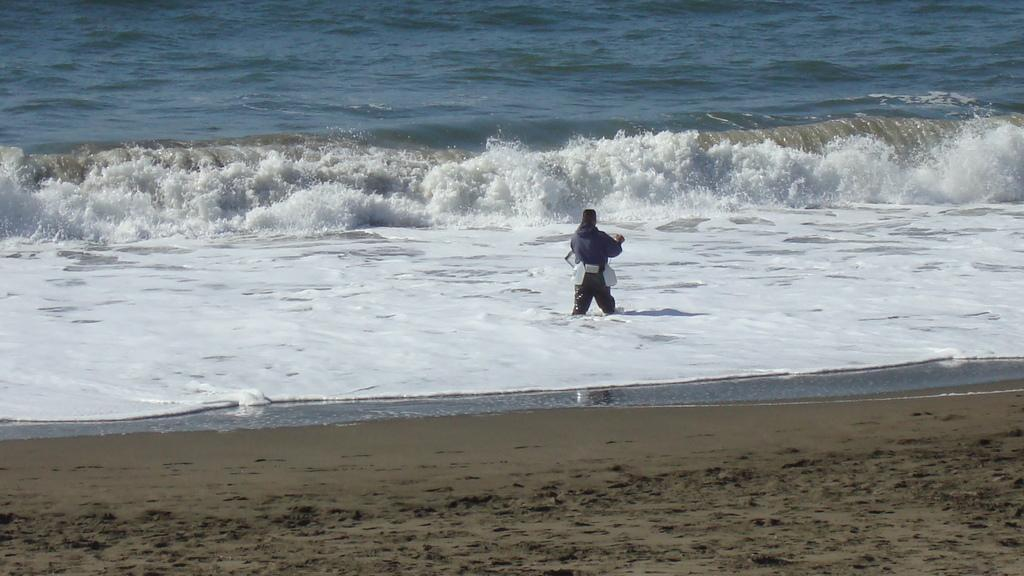What is the person in the image doing? The person is standing in the water. What can be observed about the water in the image? Waves are visible in the water, moving from left to right. What type of terrain is visible at the bottom of the picture? Sand is visible at the bottom of the picture. Can you see the family exchanging ghost stories on the sand? There is no family or ghost stories present in the image; it only shows a person standing in the water with waves and sand visible. 